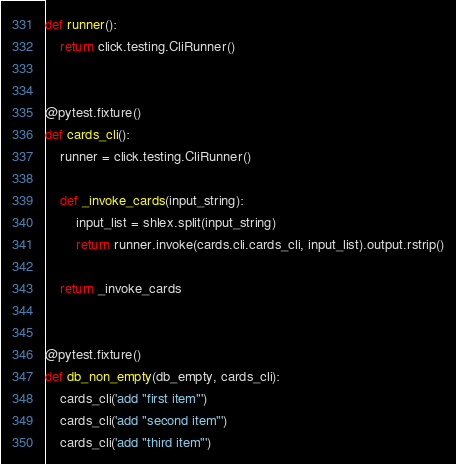<code> <loc_0><loc_0><loc_500><loc_500><_Python_>def runner():
    return click.testing.CliRunner()


@pytest.fixture()
def cards_cli():
    runner = click.testing.CliRunner()

    def _invoke_cards(input_string):
        input_list = shlex.split(input_string)
        return runner.invoke(cards.cli.cards_cli, input_list).output.rstrip()

    return _invoke_cards


@pytest.fixture()
def db_non_empty(db_empty, cards_cli):
    cards_cli('add "first item"')
    cards_cli('add "second item"')
    cards_cli('add "third item"')
</code> 